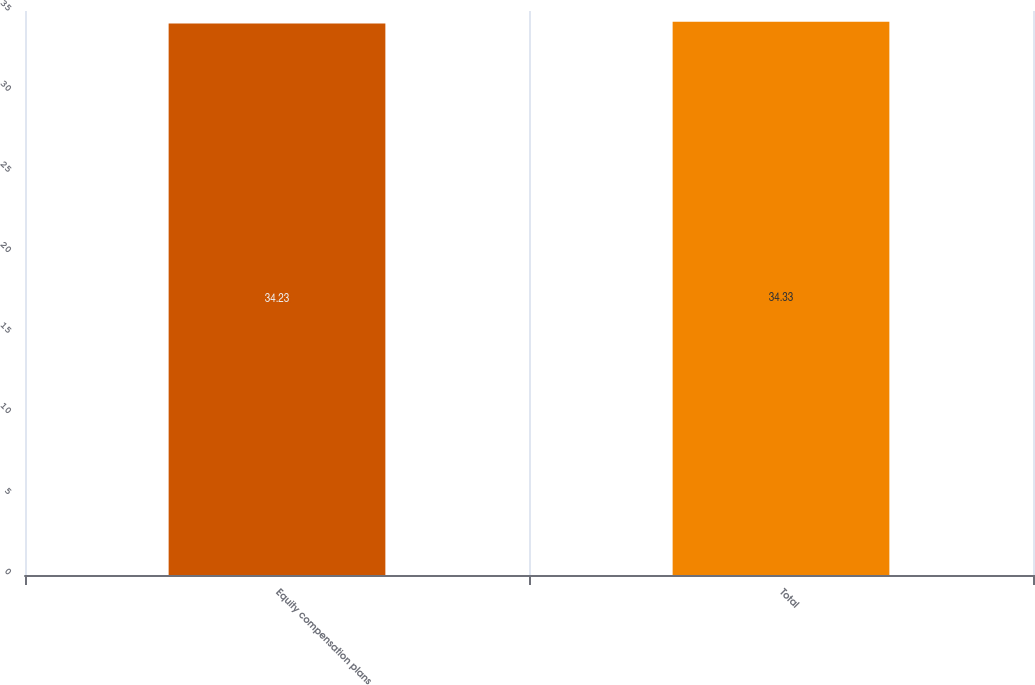Convert chart. <chart><loc_0><loc_0><loc_500><loc_500><bar_chart><fcel>Equity compensation plans<fcel>Total<nl><fcel>34.23<fcel>34.33<nl></chart> 